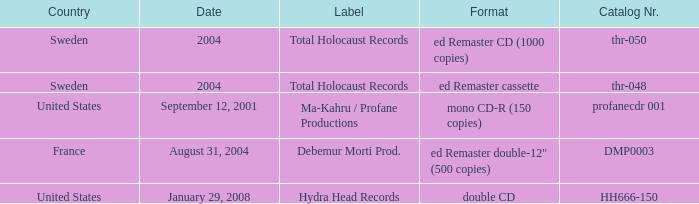Which country has the format ed Remaster double-12" (500 copies)? France. 